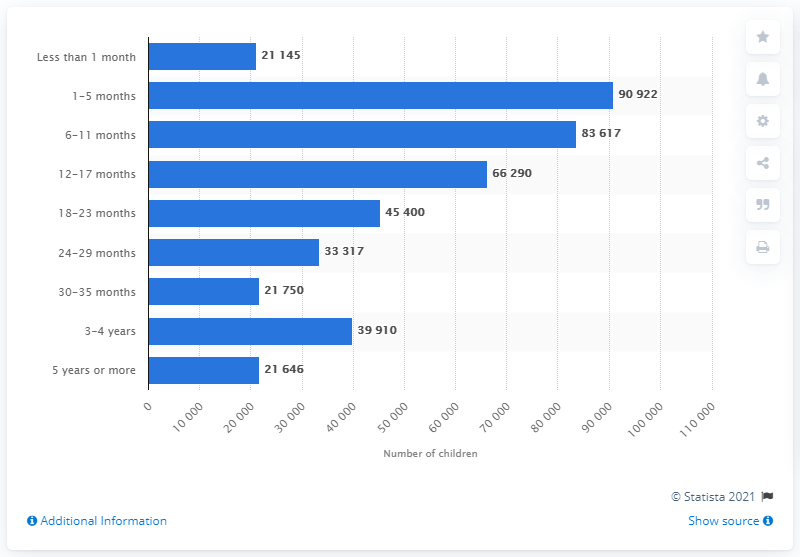Outline some significant characteristics in this image. In 2019, a significant number of children were in foster care for a period of 5 years or more. 